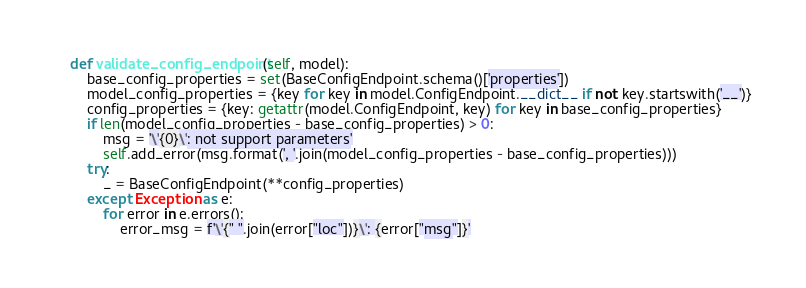Convert code to text. <code><loc_0><loc_0><loc_500><loc_500><_Python_>
    def validate_config_endpoint(self, model):
        base_config_properties = set(BaseConfigEndpoint.schema()['properties'])
        model_config_properties = {key for key in model.ConfigEndpoint.__dict__ if not key.startswith('__')}
        config_properties = {key: getattr(model.ConfigEndpoint, key) for key in base_config_properties}
        if len(model_config_properties - base_config_properties) > 0:
            msg = '\'{0}\': not support parameters'
            self.add_error(msg.format(', '.join(model_config_properties - base_config_properties)))
        try:
            _ = BaseConfigEndpoint(**config_properties)
        except Exception as e:
            for error in e.errors():
                error_msg = f'\'{" ".join(error["loc"])}\': {error["msg"]}'</code> 